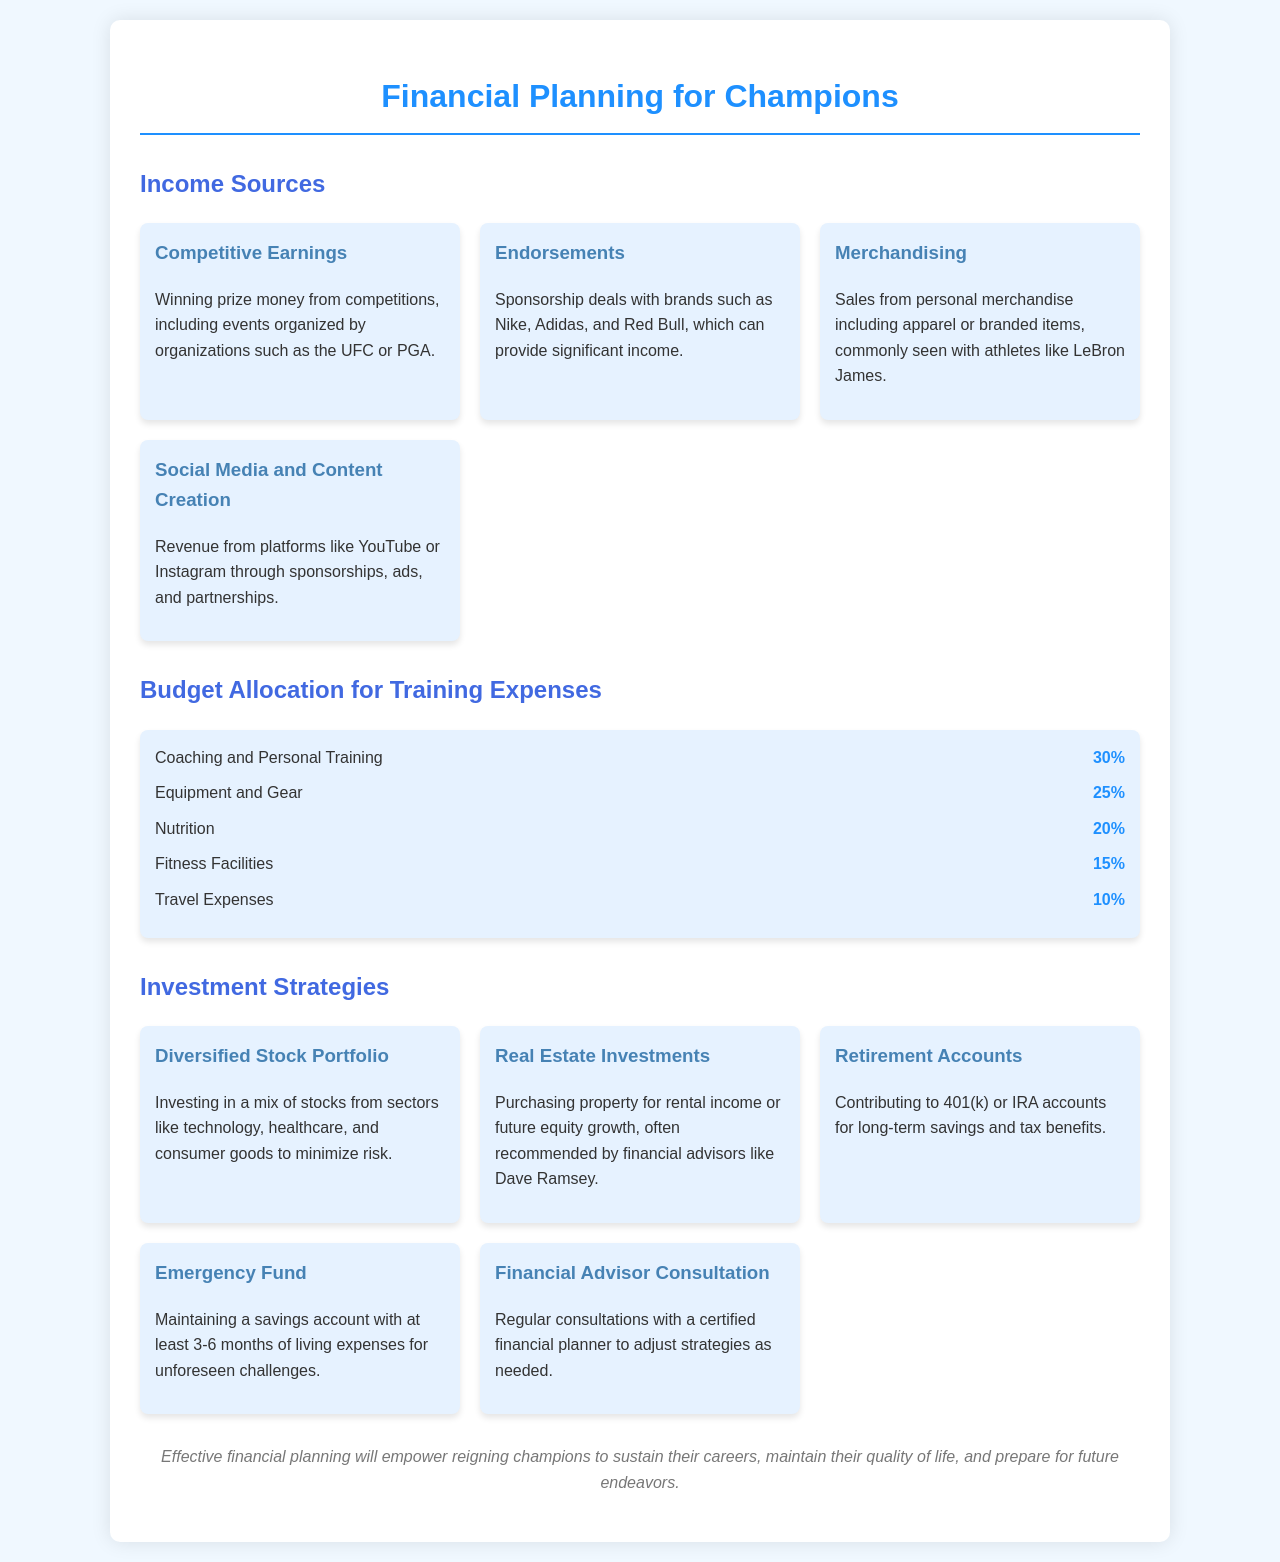what is one source of income listed for athletes? The document mentions several income sources for athletes, one of which is competitive earnings.
Answer: Competitive earnings what percentage of the budget should go to coaching and personal training? The document specifies that 30% of the budget should be allocated to coaching and personal training.
Answer: 30% name one investment strategy mentioned in the document. The document lists various investment strategies, including a diversified stock portfolio.
Answer: Diversified Stock Portfolio what is the percentage allocated for travel expenses? According to the document, 10% of the budget is allocated for travel expenses.
Answer: 10% how many main sections are there in the document? The document contains three main sections, each addressing different aspects of financial planning for athletes.
Answer: Three what is the purpose of maintaining an emergency fund? The document states that an emergency fund is meant to cover unforeseen challenges, suggesting a need for financial security.
Answer: Unforeseen challenges which income source involves social media? The document discusses income from social media and content creation as one of the income sources for athletes.
Answer: Social Media and Content Creation what percentage of the budget is dedicated to nutrition? As indicated in the document, 20% of the budget should be allocated to nutrition expenses.
Answer: 20% who is suggested for consultation regarding financial planning? The document recommends regular consultations with a certified financial planner to adjust strategies as needed.
Answer: Financial Advisor 